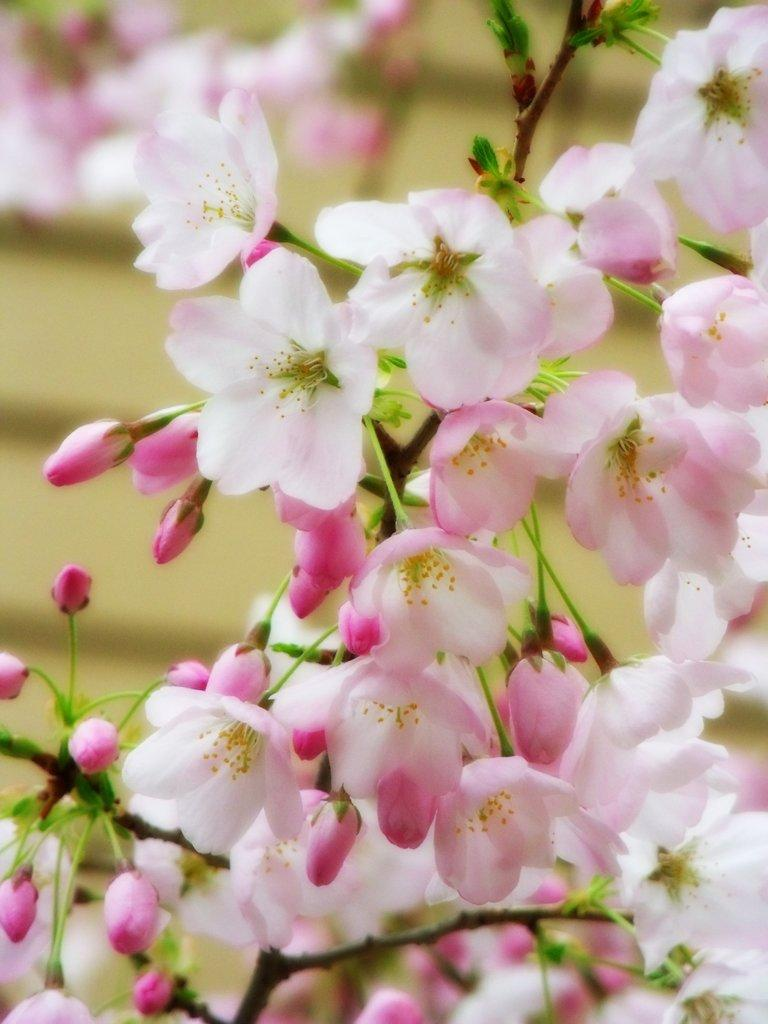What type of plant is in the image? There is a plant in the image, and it has flowers and buds. Can you describe the flowers on the plant? The flowers on the plant are visible in the image. What is the background of the image like? The background of the image is blurred. Are there any other flowers visible in the image? Yes, flowers are visible in the background. How does the plant express its feeling in the image? Plants do not have feelings, so the plant cannot express any emotions in the image. Can you see a giraffe in the image? No, there is no giraffe present in the image. 